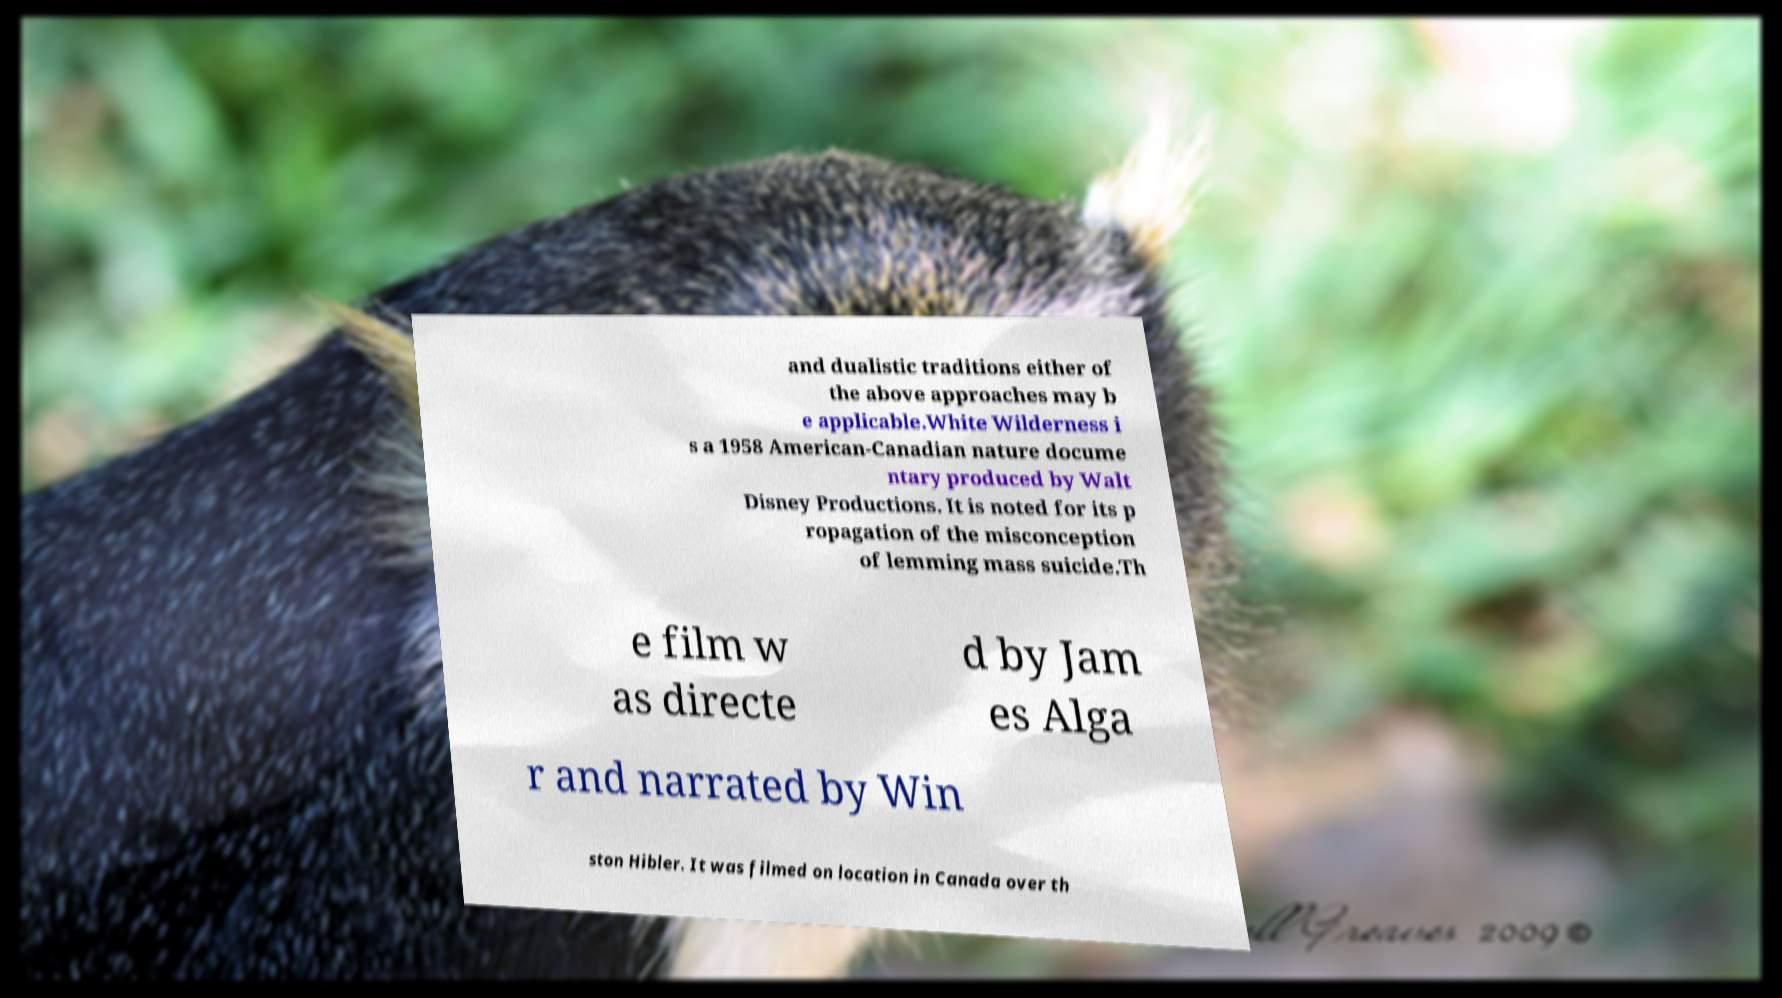Could you assist in decoding the text presented in this image and type it out clearly? and dualistic traditions either of the above approaches may b e applicable.White Wilderness i s a 1958 American-Canadian nature docume ntary produced by Walt Disney Productions. It is noted for its p ropagation of the misconception of lemming mass suicide.Th e film w as directe d by Jam es Alga r and narrated by Win ston Hibler. It was filmed on location in Canada over th 